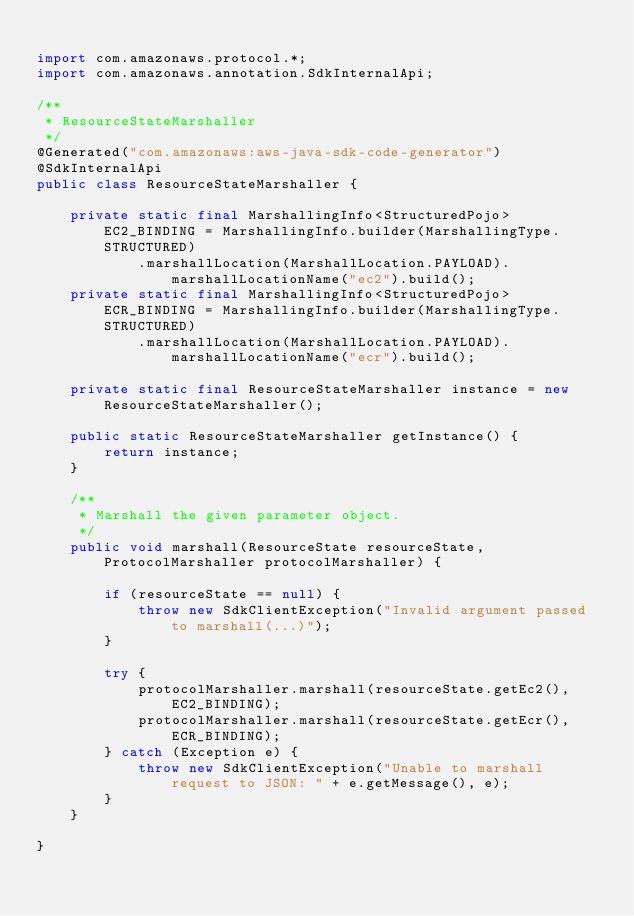Convert code to text. <code><loc_0><loc_0><loc_500><loc_500><_Java_>
import com.amazonaws.protocol.*;
import com.amazonaws.annotation.SdkInternalApi;

/**
 * ResourceStateMarshaller
 */
@Generated("com.amazonaws:aws-java-sdk-code-generator")
@SdkInternalApi
public class ResourceStateMarshaller {

    private static final MarshallingInfo<StructuredPojo> EC2_BINDING = MarshallingInfo.builder(MarshallingType.STRUCTURED)
            .marshallLocation(MarshallLocation.PAYLOAD).marshallLocationName("ec2").build();
    private static final MarshallingInfo<StructuredPojo> ECR_BINDING = MarshallingInfo.builder(MarshallingType.STRUCTURED)
            .marshallLocation(MarshallLocation.PAYLOAD).marshallLocationName("ecr").build();

    private static final ResourceStateMarshaller instance = new ResourceStateMarshaller();

    public static ResourceStateMarshaller getInstance() {
        return instance;
    }

    /**
     * Marshall the given parameter object.
     */
    public void marshall(ResourceState resourceState, ProtocolMarshaller protocolMarshaller) {

        if (resourceState == null) {
            throw new SdkClientException("Invalid argument passed to marshall(...)");
        }

        try {
            protocolMarshaller.marshall(resourceState.getEc2(), EC2_BINDING);
            protocolMarshaller.marshall(resourceState.getEcr(), ECR_BINDING);
        } catch (Exception e) {
            throw new SdkClientException("Unable to marshall request to JSON: " + e.getMessage(), e);
        }
    }

}
</code> 